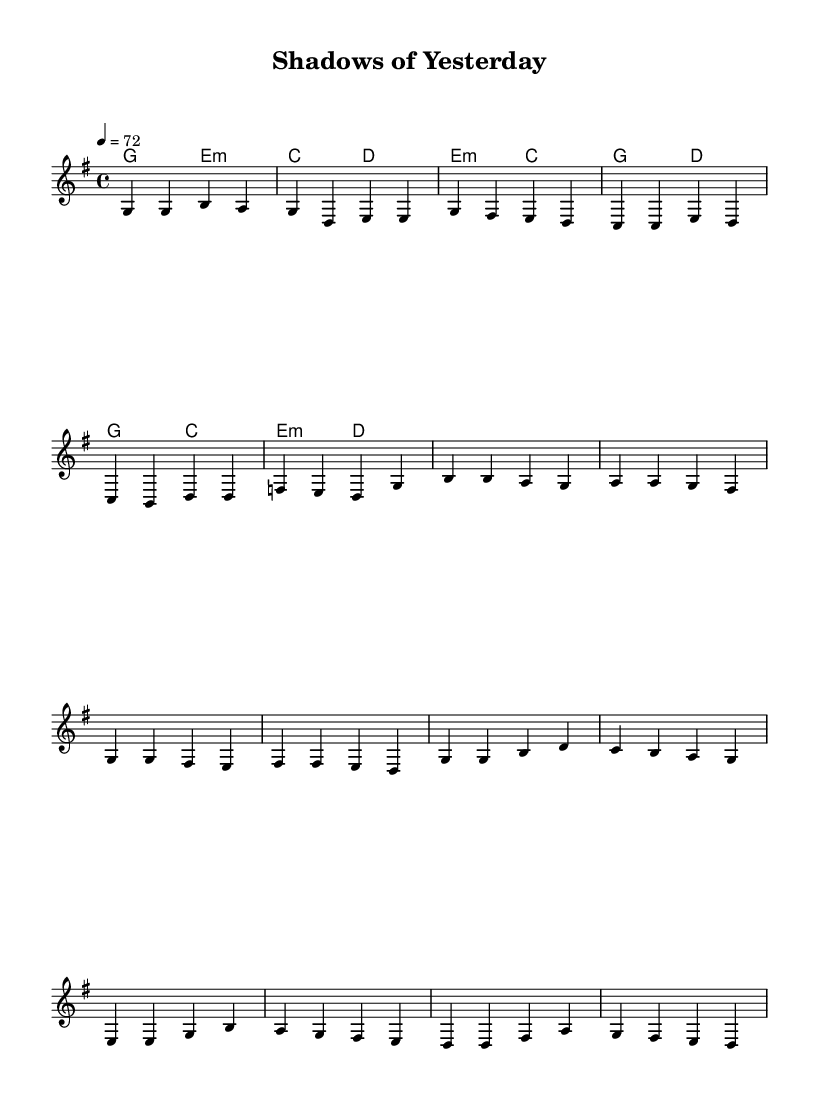What is the key signature of this music? The key signature is determined by the presence of sharps or flats indicated at the beginning of the staff. Here, there is one sharp (F#), which indicates that the key is G major.
Answer: G major What is the time signature of this music? The time signature is displayed at the beginning of the staff, showing how many beats are in each measure. In this case, it shows 4/4, meaning there are four beats in each measure.
Answer: 4/4 What is the tempo marking of this music? The tempo marking is based on the instruction given in the score, indicated as "4 = 72." This means there are 72 beats per minute.
Answer: 72 How many distinct sections does this piece have? The sheet music includes a distinct structure: verses, a pre-chorus, and a chorus. By counting each of these sections, we identify three distinct parts.
Answer: Three What chord follows the first G major chord in the verse? In the verse, after the G major chord (G2), the next chord indicated is E minor (e:m), which is the second chord in that section.
Answer: E minor Which musical structure is commonly found in pop ballads, as seen in this music? Pop ballads typically follow a clear structure of verses, chorus, and often a bridge. In this piece, we see verses, a pre-chorus, and a chorus, indicative of that structure.
Answer: Verse-pre-chorus-chorus 